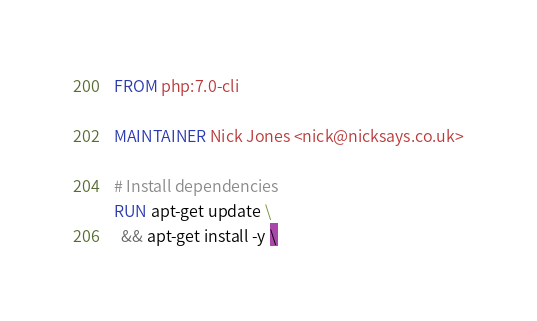Convert code to text. <code><loc_0><loc_0><loc_500><loc_500><_Dockerfile_>FROM php:7.0-cli

MAINTAINER Nick Jones <nick@nicksays.co.uk>

# Install dependencies
RUN apt-get update \
  && apt-get install -y \</code> 